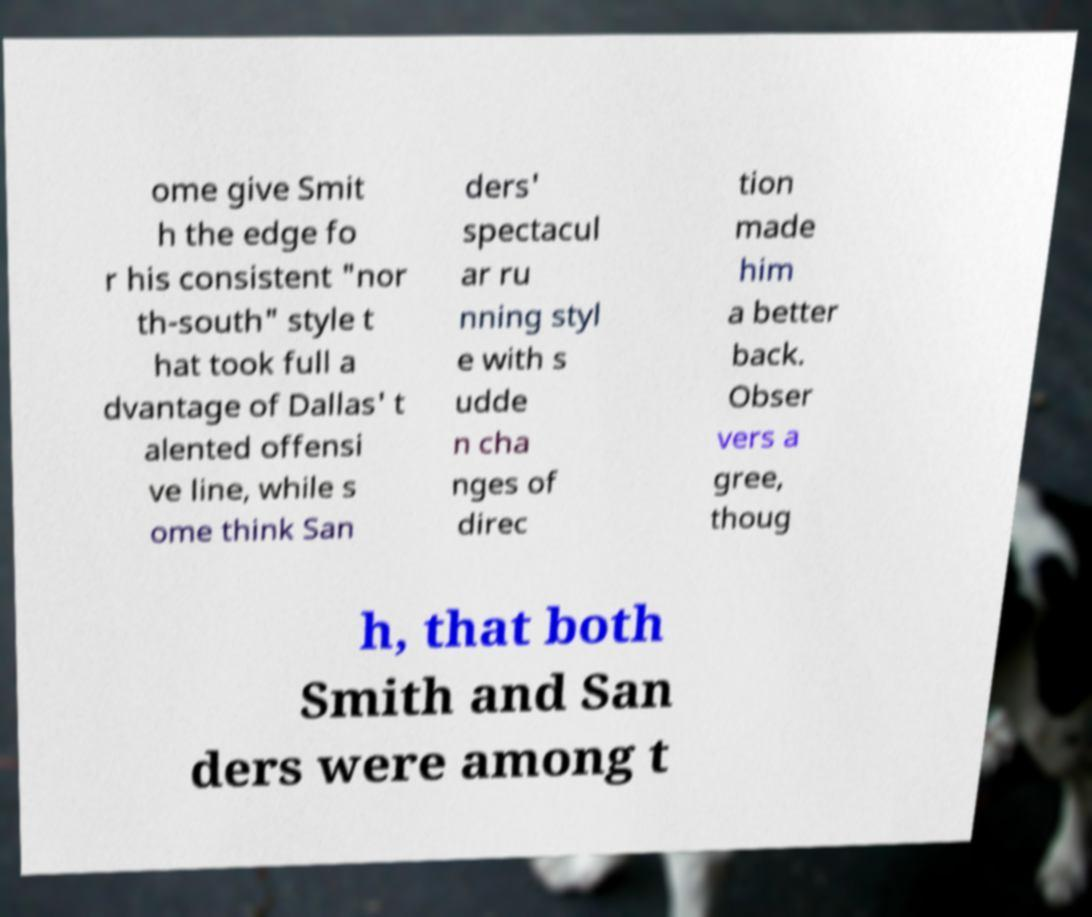Could you assist in decoding the text presented in this image and type it out clearly? ome give Smit h the edge fo r his consistent "nor th-south" style t hat took full a dvantage of Dallas' t alented offensi ve line, while s ome think San ders' spectacul ar ru nning styl e with s udde n cha nges of direc tion made him a better back. Obser vers a gree, thoug h, that both Smith and San ders were among t 